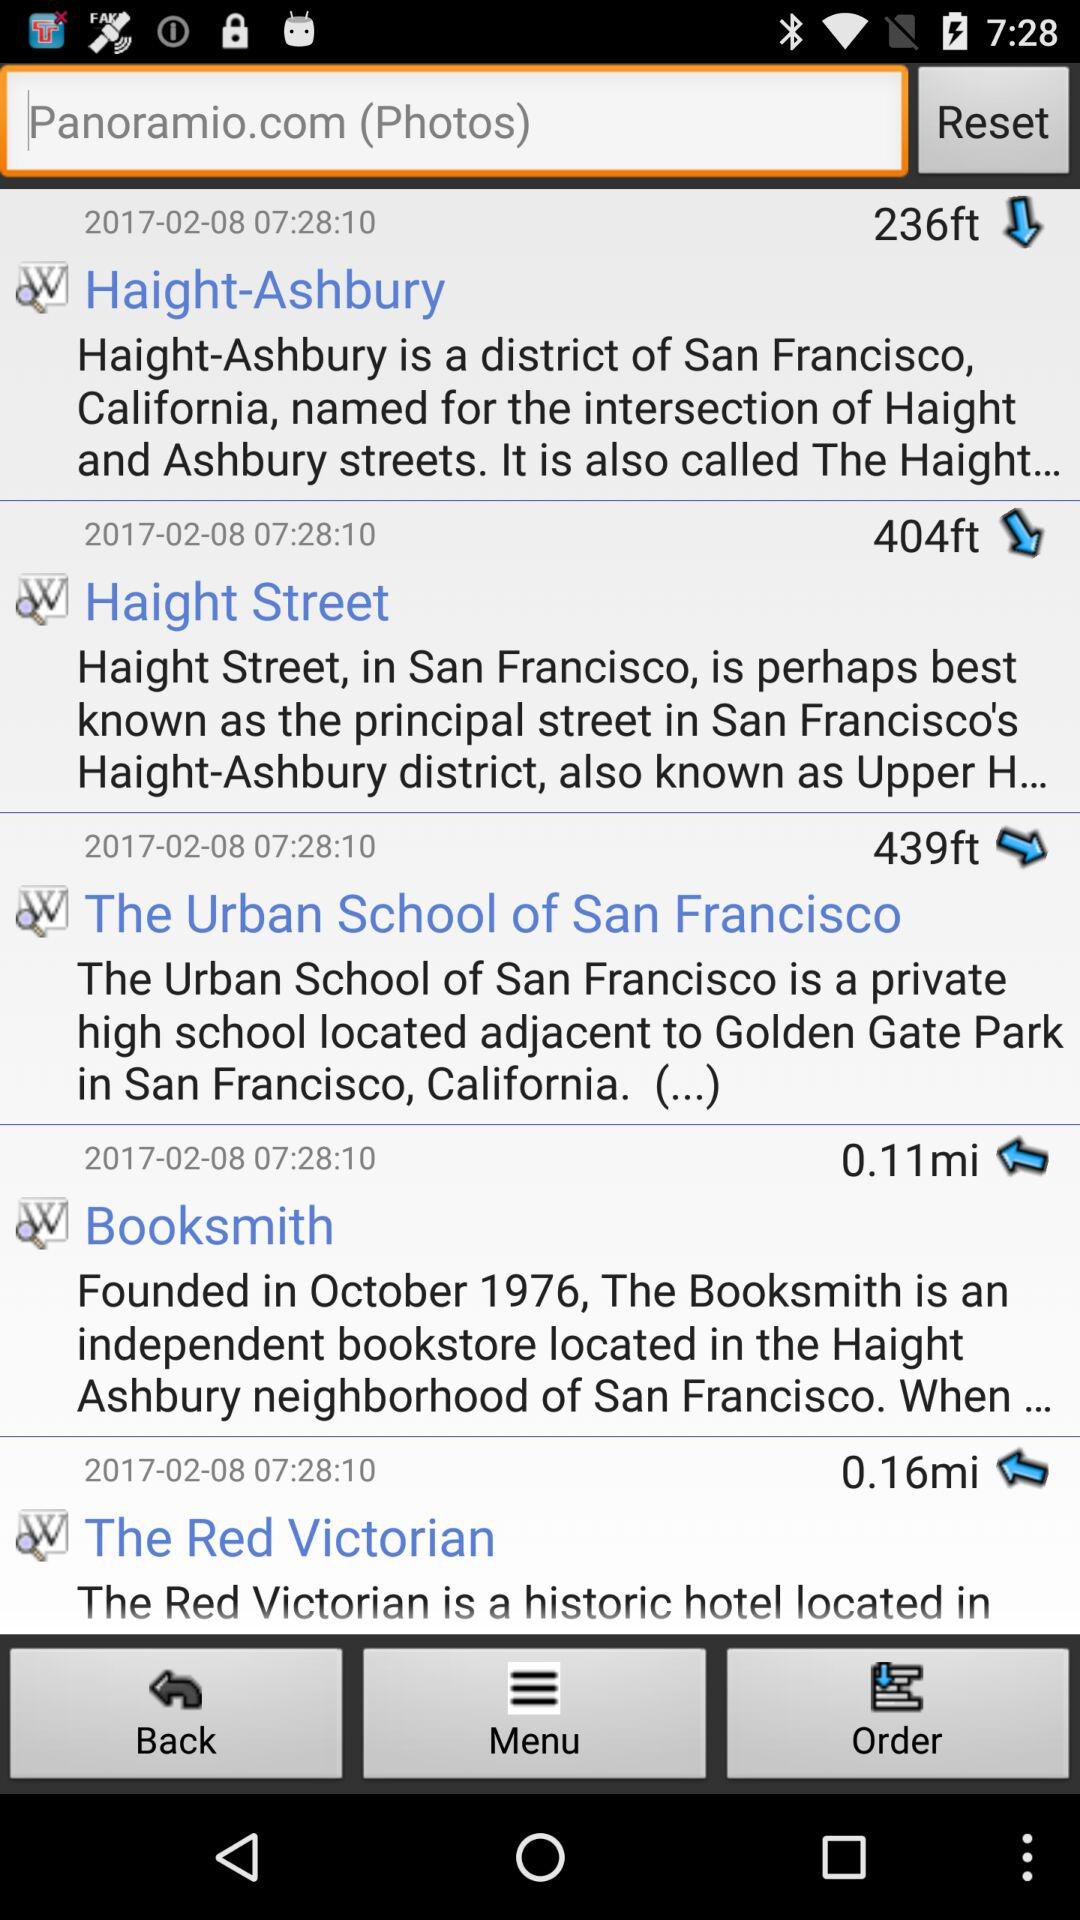Where is the Red Victorian hotel located?
When the provided information is insufficient, respond with <no answer>. <no answer> 